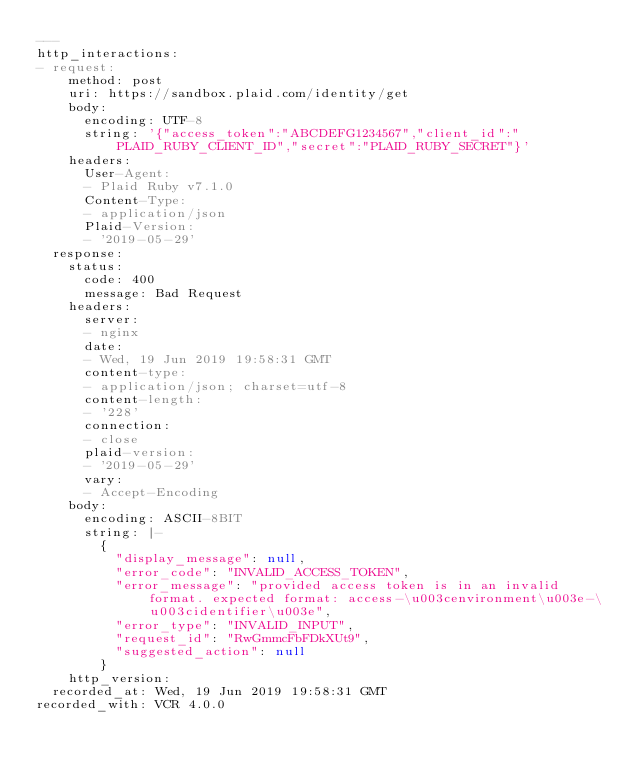<code> <loc_0><loc_0><loc_500><loc_500><_YAML_>---
http_interactions:
- request:
    method: post
    uri: https://sandbox.plaid.com/identity/get
    body:
      encoding: UTF-8
      string: '{"access_token":"ABCDEFG1234567","client_id":"PLAID_RUBY_CLIENT_ID","secret":"PLAID_RUBY_SECRET"}'
    headers:
      User-Agent:
      - Plaid Ruby v7.1.0
      Content-Type:
      - application/json
      Plaid-Version:
      - '2019-05-29'
  response:
    status:
      code: 400
      message: Bad Request
    headers:
      server:
      - nginx
      date:
      - Wed, 19 Jun 2019 19:58:31 GMT
      content-type:
      - application/json; charset=utf-8
      content-length:
      - '228'
      connection:
      - close
      plaid-version:
      - '2019-05-29'
      vary:
      - Accept-Encoding
    body:
      encoding: ASCII-8BIT
      string: |-
        {
          "display_message": null,
          "error_code": "INVALID_ACCESS_TOKEN",
          "error_message": "provided access token is in an invalid format. expected format: access-\u003cenvironment\u003e-\u003cidentifier\u003e",
          "error_type": "INVALID_INPUT",
          "request_id": "RwGmmcFbFDkXUt9",
          "suggested_action": null
        }
    http_version: 
  recorded_at: Wed, 19 Jun 2019 19:58:31 GMT
recorded_with: VCR 4.0.0
</code> 